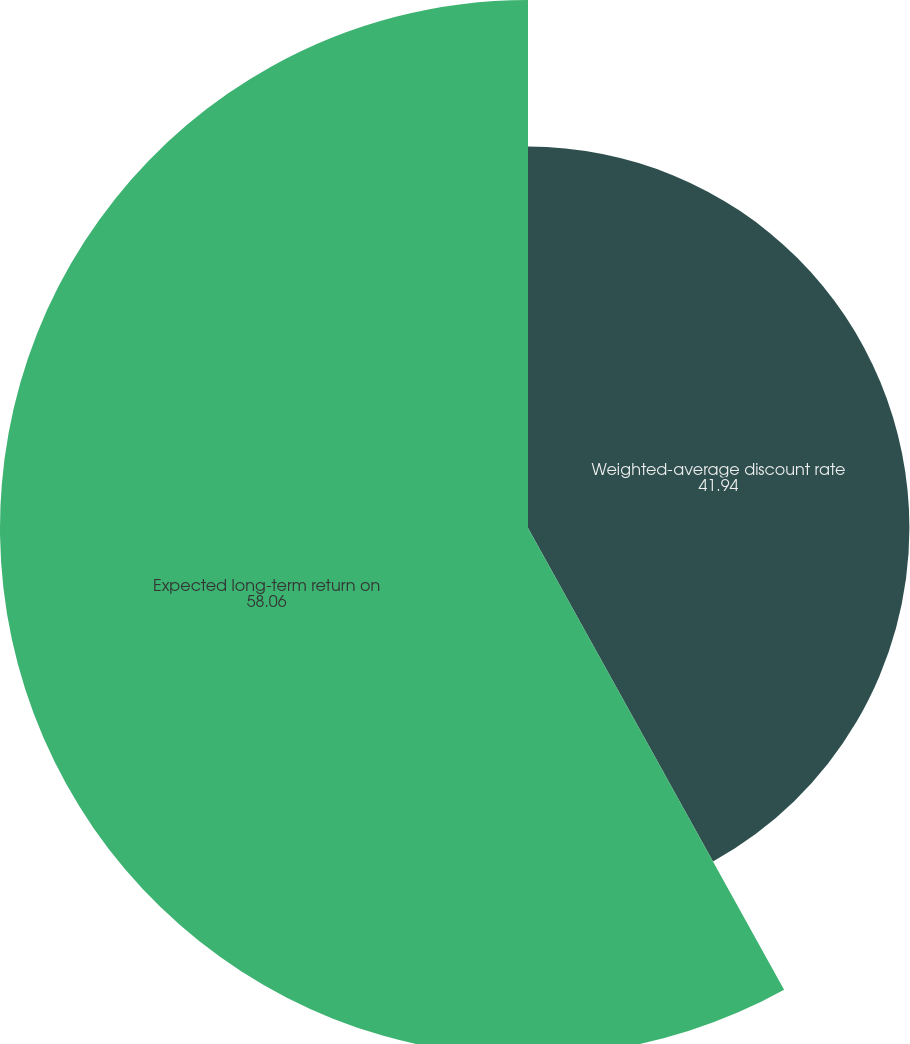Convert chart to OTSL. <chart><loc_0><loc_0><loc_500><loc_500><pie_chart><fcel>Weighted-average discount rate<fcel>Expected long-term return on<nl><fcel>41.94%<fcel>58.06%<nl></chart> 